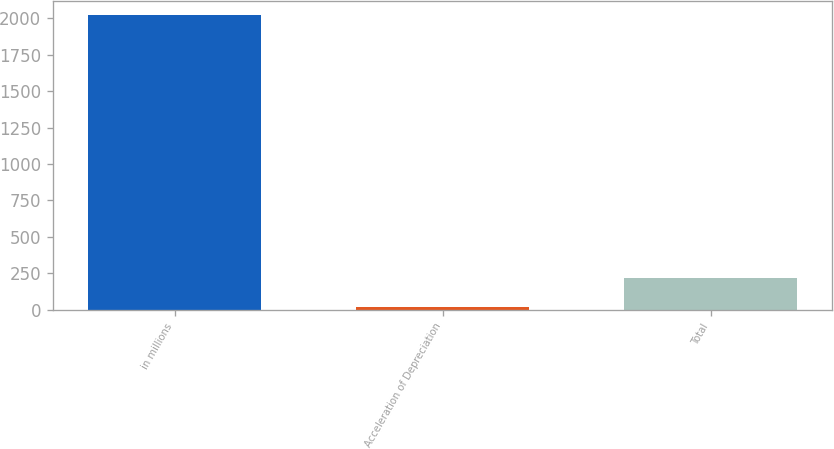Convert chart. <chart><loc_0><loc_0><loc_500><loc_500><bar_chart><fcel>in millions<fcel>Acceleration of Depreciation<fcel>Total<nl><fcel>2018<fcel>17<fcel>217.1<nl></chart> 